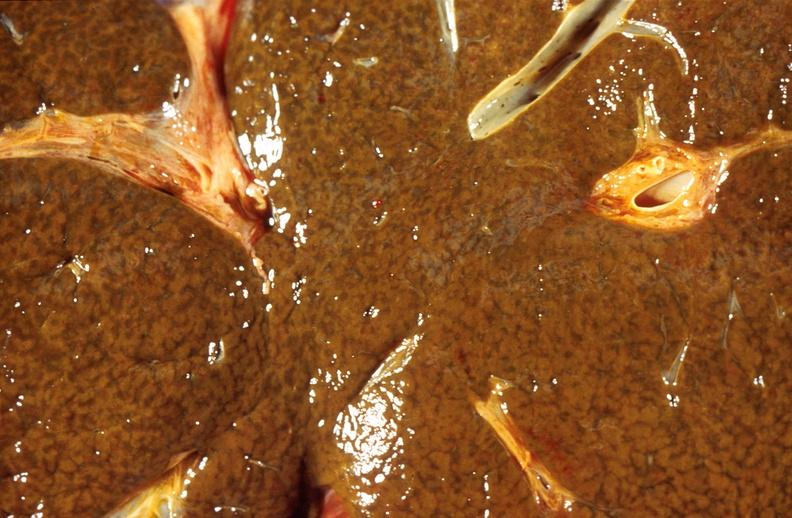what does this image show?
Answer the question using a single word or phrase. Liver 